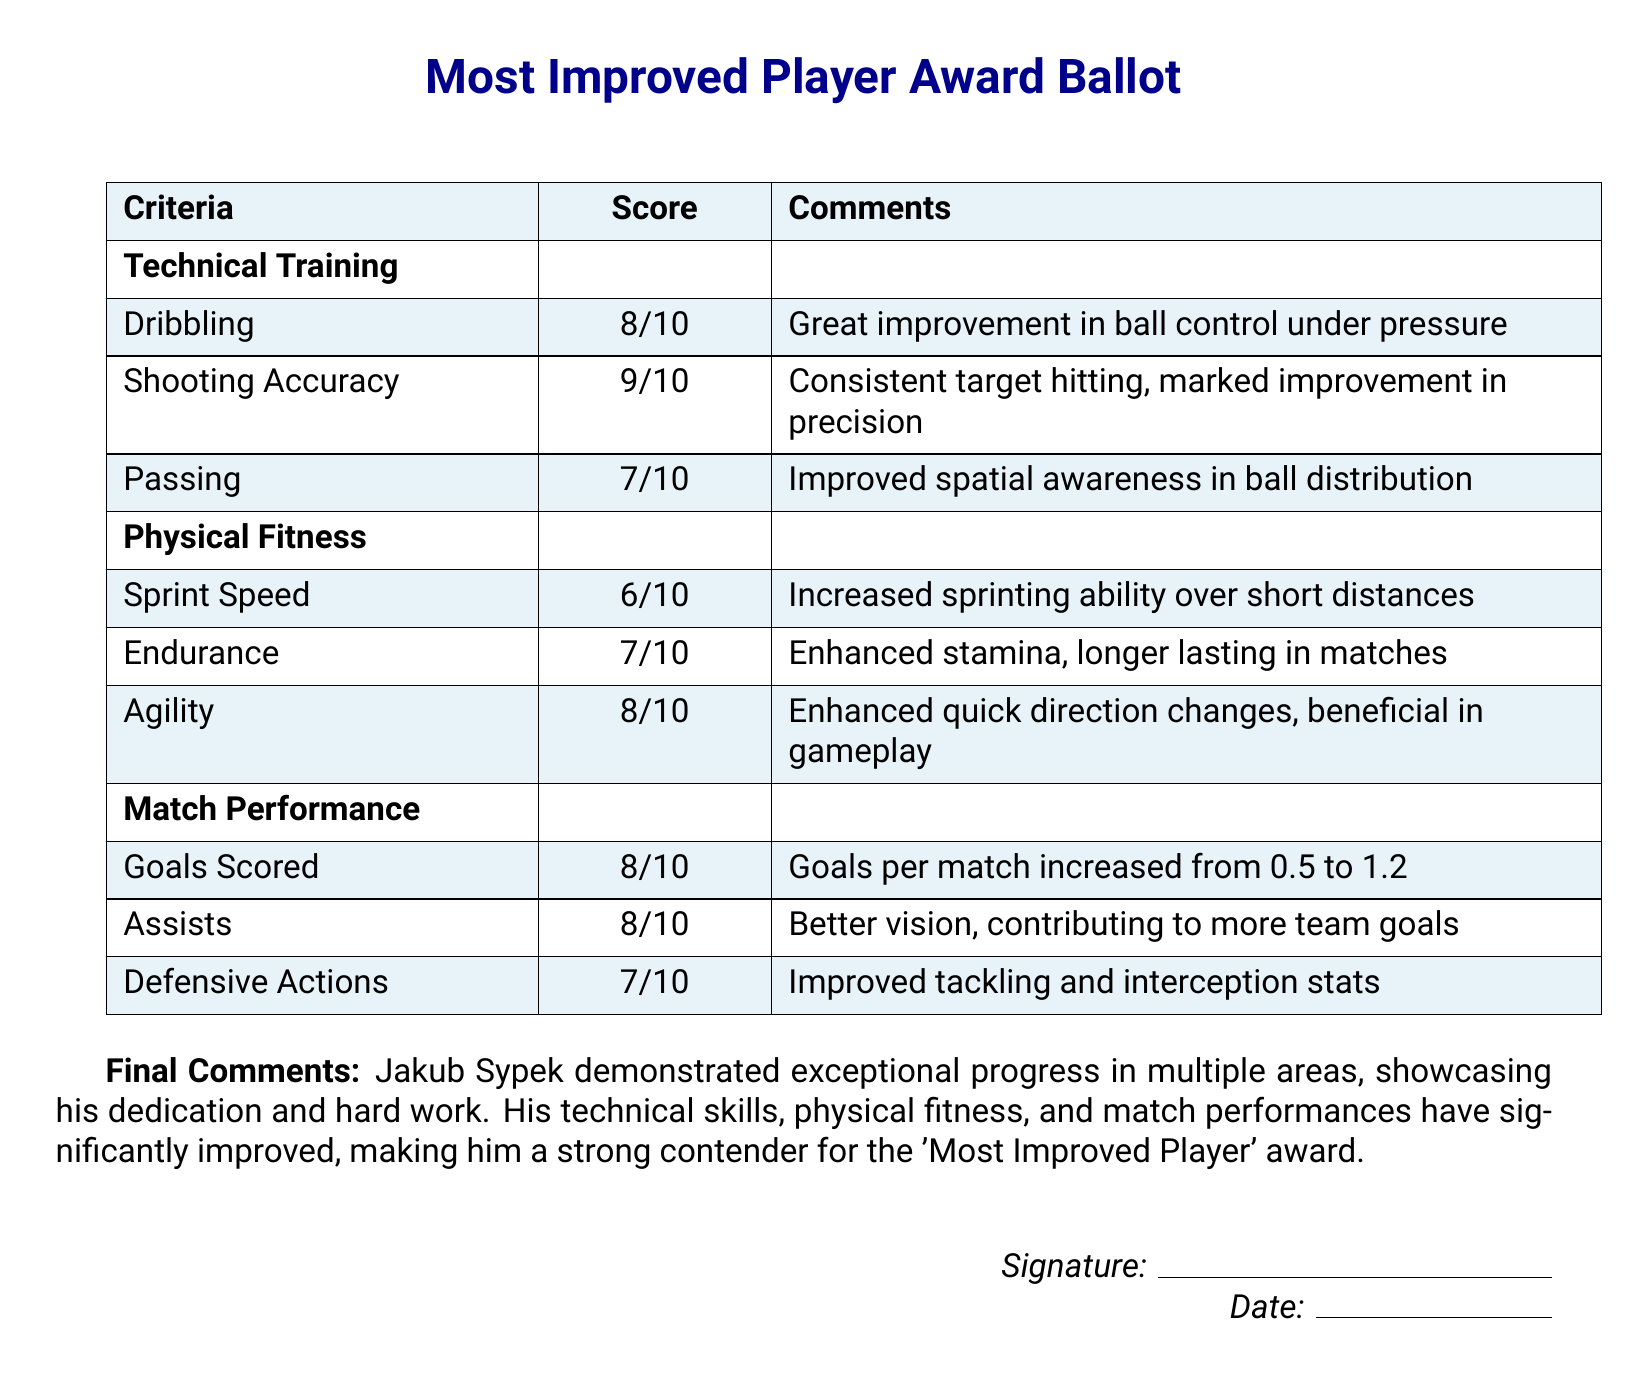What is the maximum score for shooting accuracy? The maximum score given for shooting accuracy is indicated in the score column of the ballot, which is 9/10.
Answer: 9/10 How many goals per match did Jakub Sypek score before improvement? The document states that his goals per match increased from 0.5 to 1.2, indicating the prior score of 0.5.
Answer: 0.5 What aspect of physical fitness received the lowest score? The lowest score for physical fitness can be found by comparing the scores listed, which is 6/10 for sprint speed.
Answer: Sprint Speed What is the total score for technical training? The total score can be calculated by adding individual scores for dribbling, shooting accuracy, and passing, resulting in 8 + 9 + 7 = 24 out of a possible 30.
Answer: 24 Who is the candidate for the 'Most Improved Player' award? The document specifies Jakub Sypek as the candidate for the award in the final comments.
Answer: Jakub Sypek Which skill area shows the highest improvement based on the scores? The highest score in the technical training section is in shooting accuracy, which highlights the most improvement, rated at 9/10.
Answer: Shooting Accuracy What is the date section for on the ballot? The date section is included for the individual filling out the ballot to provide a date of completion or submission.
Answer: Date How many total criteria areas are evaluated in the ballot? The areas evaluated are clearly separated section-wise, totaling three: Technical Training, Physical Fitness, and Match Performance.
Answer: Three 